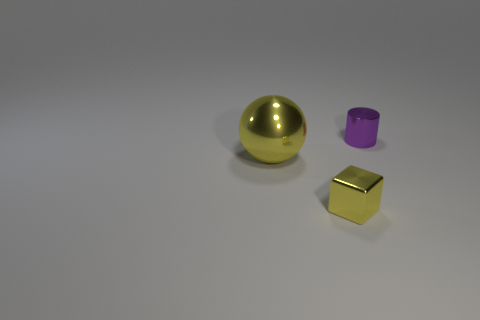What is the color of the metal object that is the same size as the yellow metallic block?
Offer a terse response. Purple. What number of metallic balls are right of the purple shiny cylinder?
Offer a very short reply. 0. Are any large red cylinders visible?
Your response must be concise. No. How big is the yellow thing behind the small metallic object in front of the tiny metal thing behind the yellow sphere?
Your response must be concise. Large. What number of other things are there of the same size as the cube?
Give a very brief answer. 1. There is a thing that is left of the yellow cube; what size is it?
Your answer should be very brief. Large. Is there any other thing that has the same color as the metallic cylinder?
Your answer should be very brief. No. Is the small thing that is behind the small yellow object made of the same material as the big sphere?
Provide a succinct answer. Yes. What number of objects are on the right side of the big metal sphere and behind the yellow block?
Offer a very short reply. 1. There is a yellow metal thing that is on the left side of the tiny object in front of the tiny purple thing; how big is it?
Offer a terse response. Large. 